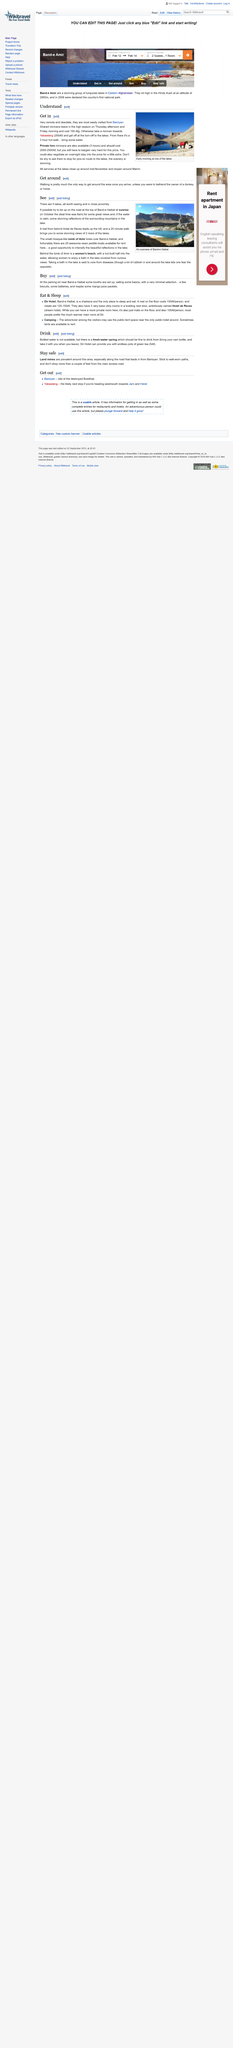Mention a couple of crucial points in this snapshot. Yes, private hire minivans are available, and their cost is estimated to be between 2000-2500 Af. However, it is advisable to bargain hard to obtain this price. The caption of the photo in the article "Understand" declares that it shows "Early morning at one of the lakes. Shared minivans to Bamiyan depart in the high season on Thursday afternoons and Friday mornings. 